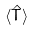<formula> <loc_0><loc_0><loc_500><loc_500>\langle \hat { T } \rangle</formula> 